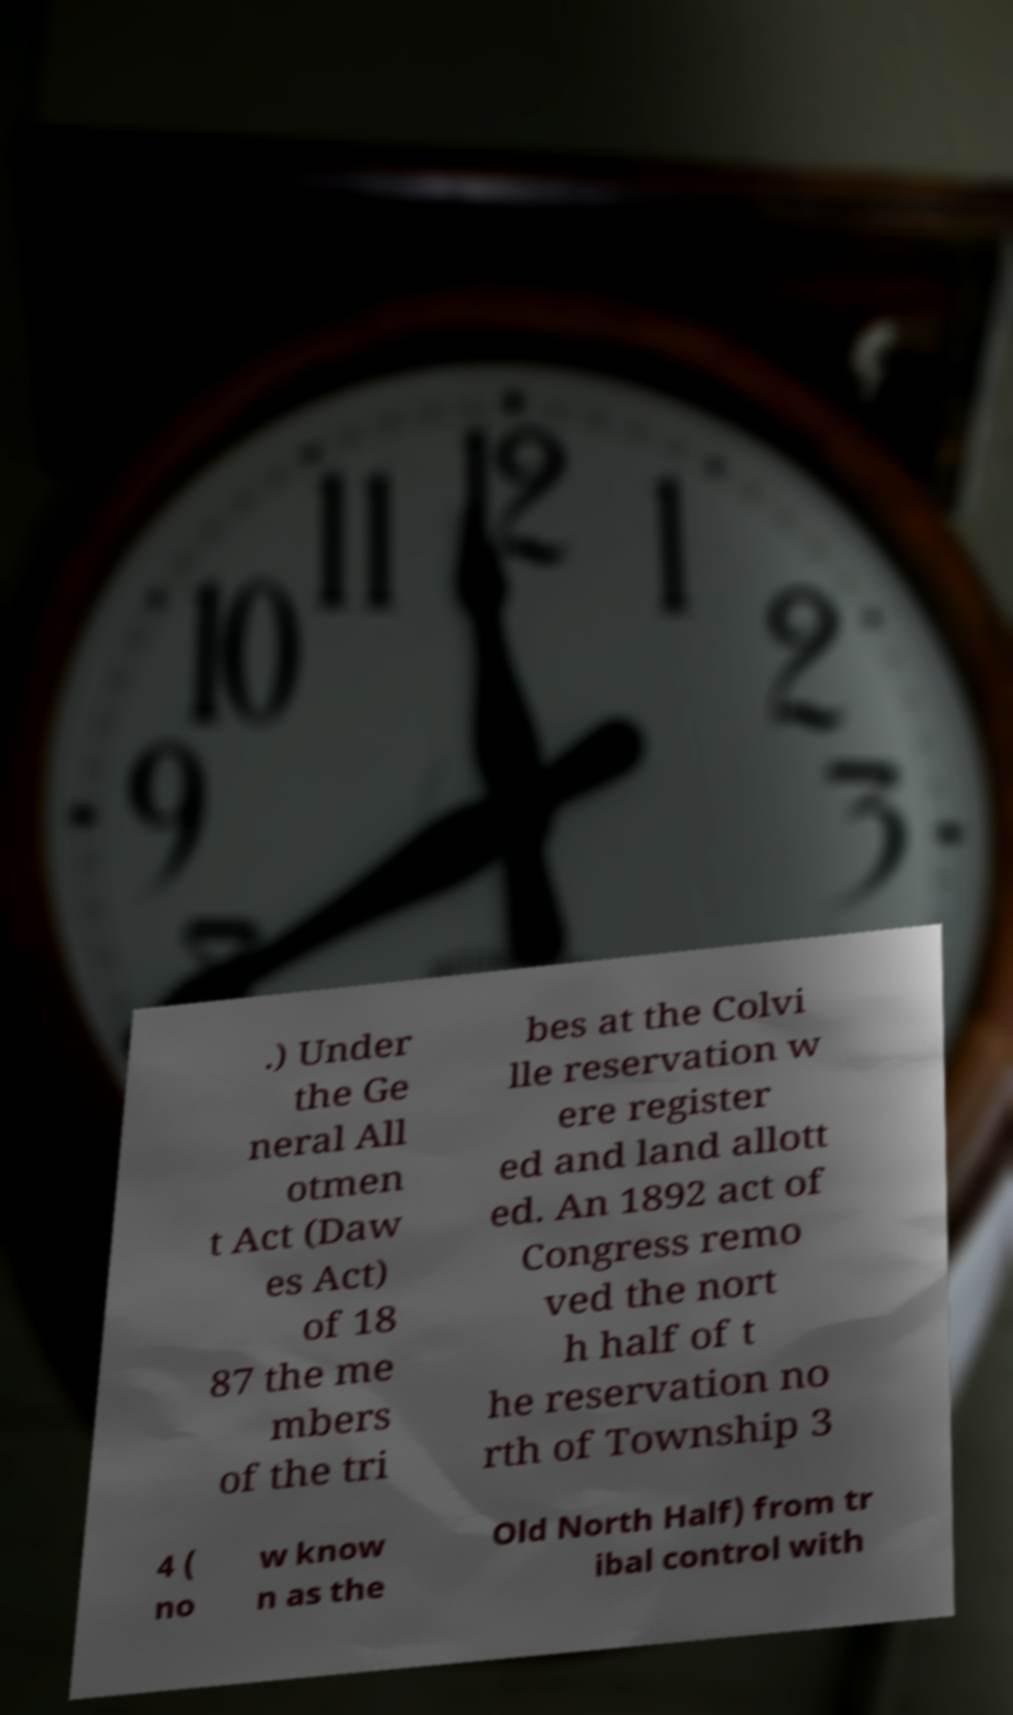Can you accurately transcribe the text from the provided image for me? .) Under the Ge neral All otmen t Act (Daw es Act) of 18 87 the me mbers of the tri bes at the Colvi lle reservation w ere register ed and land allott ed. An 1892 act of Congress remo ved the nort h half of t he reservation no rth of Township 3 4 ( no w know n as the Old North Half) from tr ibal control with 